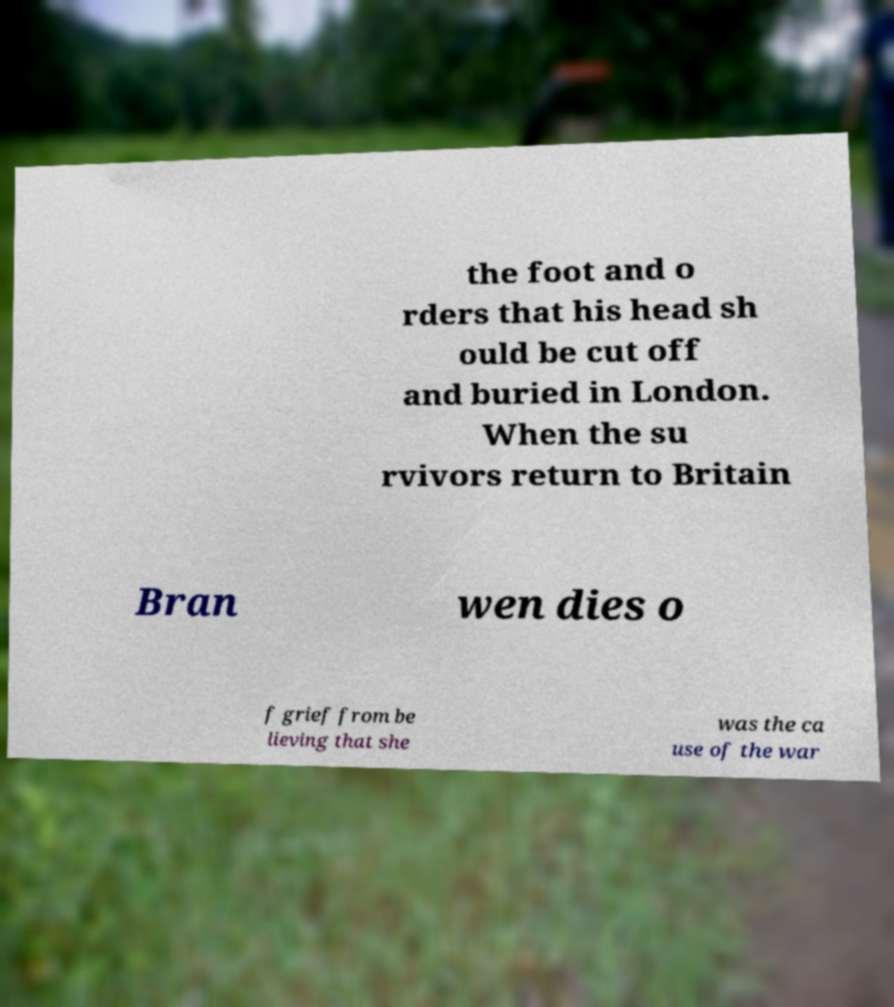Please read and relay the text visible in this image. What does it say? the foot and o rders that his head sh ould be cut off and buried in London. When the su rvivors return to Britain Bran wen dies o f grief from be lieving that she was the ca use of the war 